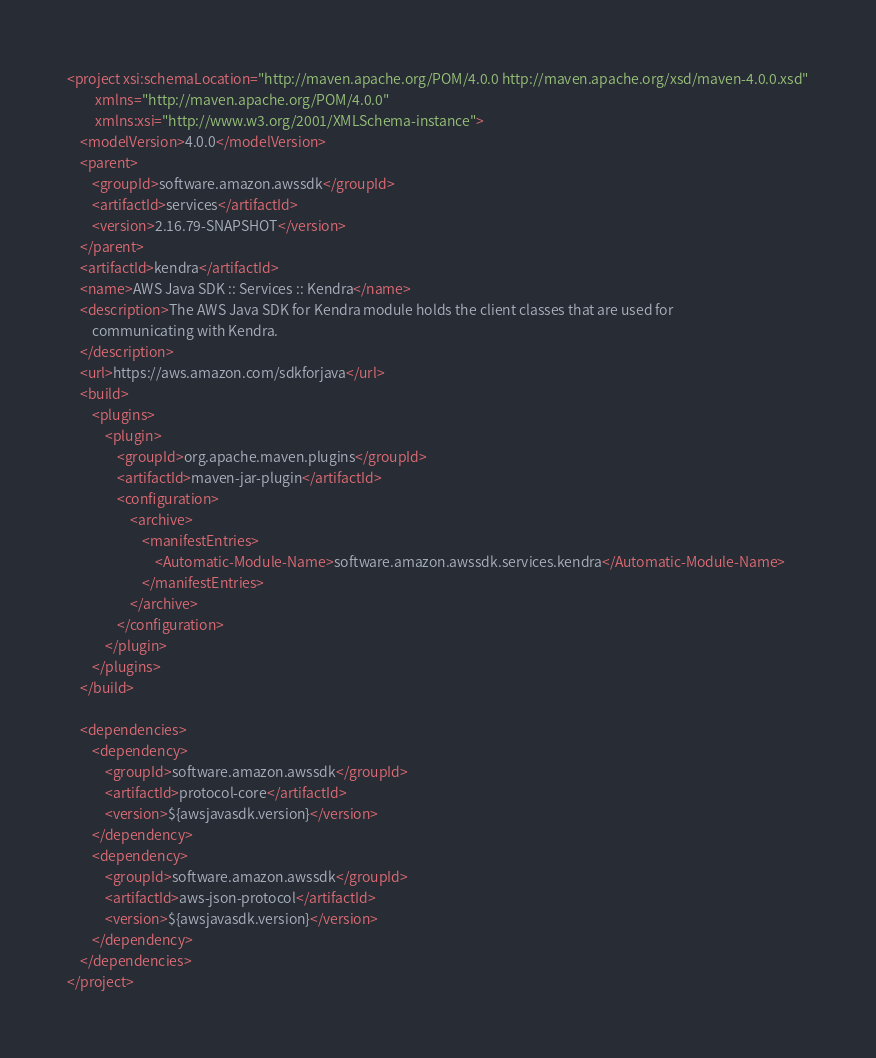Convert code to text. <code><loc_0><loc_0><loc_500><loc_500><_XML_><project xsi:schemaLocation="http://maven.apache.org/POM/4.0.0 http://maven.apache.org/xsd/maven-4.0.0.xsd"
         xmlns="http://maven.apache.org/POM/4.0.0"
         xmlns:xsi="http://www.w3.org/2001/XMLSchema-instance">
    <modelVersion>4.0.0</modelVersion>
    <parent>
        <groupId>software.amazon.awssdk</groupId>
        <artifactId>services</artifactId>
        <version>2.16.79-SNAPSHOT</version>
    </parent>
    <artifactId>kendra</artifactId>
    <name>AWS Java SDK :: Services :: Kendra</name>
    <description>The AWS Java SDK for Kendra module holds the client classes that are used for
        communicating with Kendra.
    </description>
    <url>https://aws.amazon.com/sdkforjava</url>
    <build>
        <plugins>
            <plugin>
                <groupId>org.apache.maven.plugins</groupId>
                <artifactId>maven-jar-plugin</artifactId>
                <configuration>
                    <archive>
                        <manifestEntries>
                            <Automatic-Module-Name>software.amazon.awssdk.services.kendra</Automatic-Module-Name>
                        </manifestEntries>
                    </archive>
                </configuration>
            </plugin>
        </plugins>
    </build>

    <dependencies>
        <dependency>
            <groupId>software.amazon.awssdk</groupId>
            <artifactId>protocol-core</artifactId>
            <version>${awsjavasdk.version}</version>
        </dependency>
        <dependency>
            <groupId>software.amazon.awssdk</groupId>
            <artifactId>aws-json-protocol</artifactId>
            <version>${awsjavasdk.version}</version>
        </dependency>
    </dependencies>
</project>
</code> 